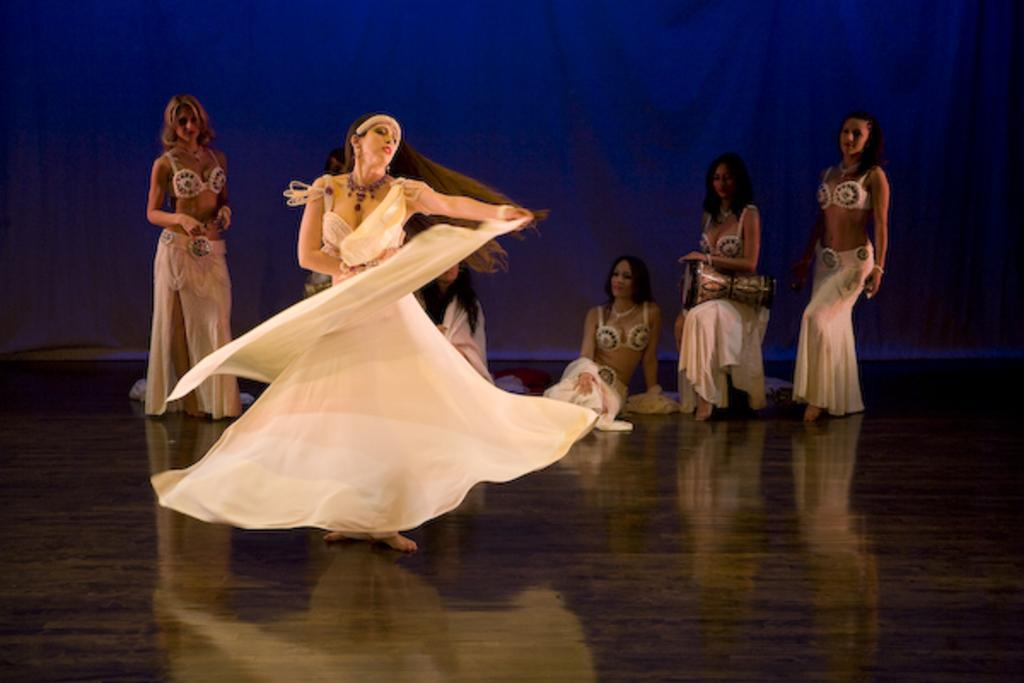How many people are in the image? There are people in the image. What type of flooring is visible in the image? There is a wooden floor in the image. What color is the curtain in the image? There is a blue curtain in the image. What is one person doing in the image? One person is dancing in the image. What musical instrument is near the person dancing? There is a musical drum near the person dancing. How many bikes are parked near the dancing person in the image? There are no bikes present in the image. What advice would the dancing person's grandmother give in the image? There is no grandmother present in the image, so it is not possible to determine what advice she might give. 